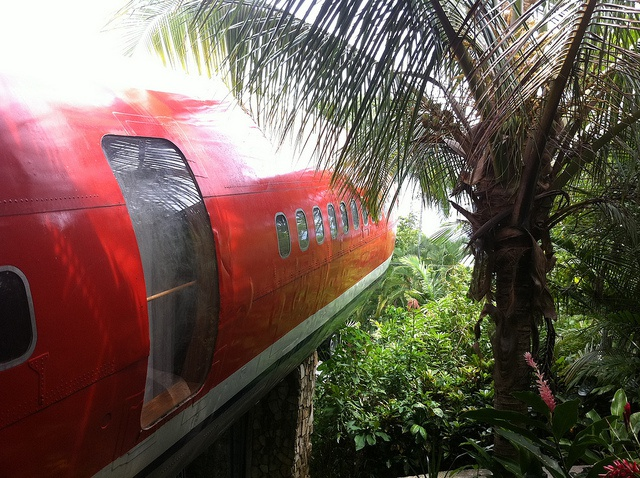Describe the objects in this image and their specific colors. I can see a airplane in white, black, maroon, and gray tones in this image. 